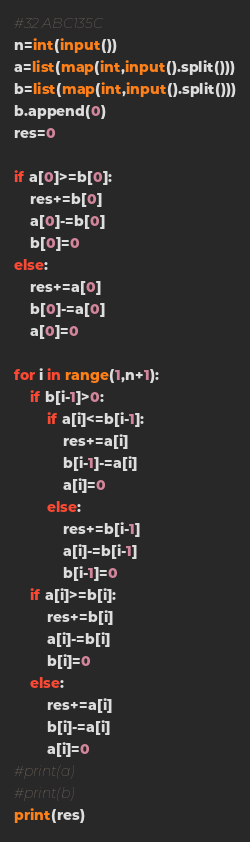Convert code to text. <code><loc_0><loc_0><loc_500><loc_500><_Python_>#32 ABC135C
n=int(input())
a=list(map(int,input().split()))
b=list(map(int,input().split()))
b.append(0)
res=0

if a[0]>=b[0]:
	res+=b[0]
	a[0]-=b[0]
	b[0]=0
else:
	res+=a[0]
	b[0]-=a[0]
	a[0]=0

for i in range(1,n+1):
	if b[i-1]>0:
		if a[i]<=b[i-1]:
			res+=a[i]
			b[i-1]-=a[i]
			a[i]=0
		else:
			res+=b[i-1]
			a[i]-=b[i-1]
			b[i-1]=0
	if a[i]>=b[i]:
		res+=b[i]
		a[i]-=b[i]
		b[i]=0
	else:
		res+=a[i]
		b[i]-=a[i]
		a[i]=0
#print(a)
#print(b)
print(res)</code> 